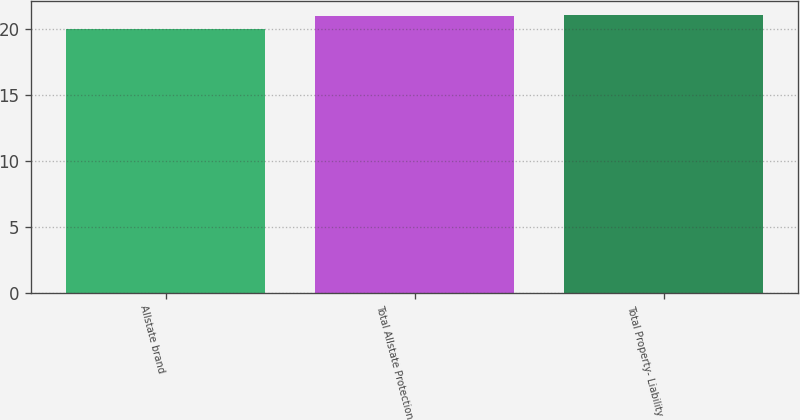Convert chart. <chart><loc_0><loc_0><loc_500><loc_500><bar_chart><fcel>Allstate brand<fcel>Total Allstate Protection<fcel>Total Property- Liability<nl><fcel>20<fcel>21<fcel>21.1<nl></chart> 